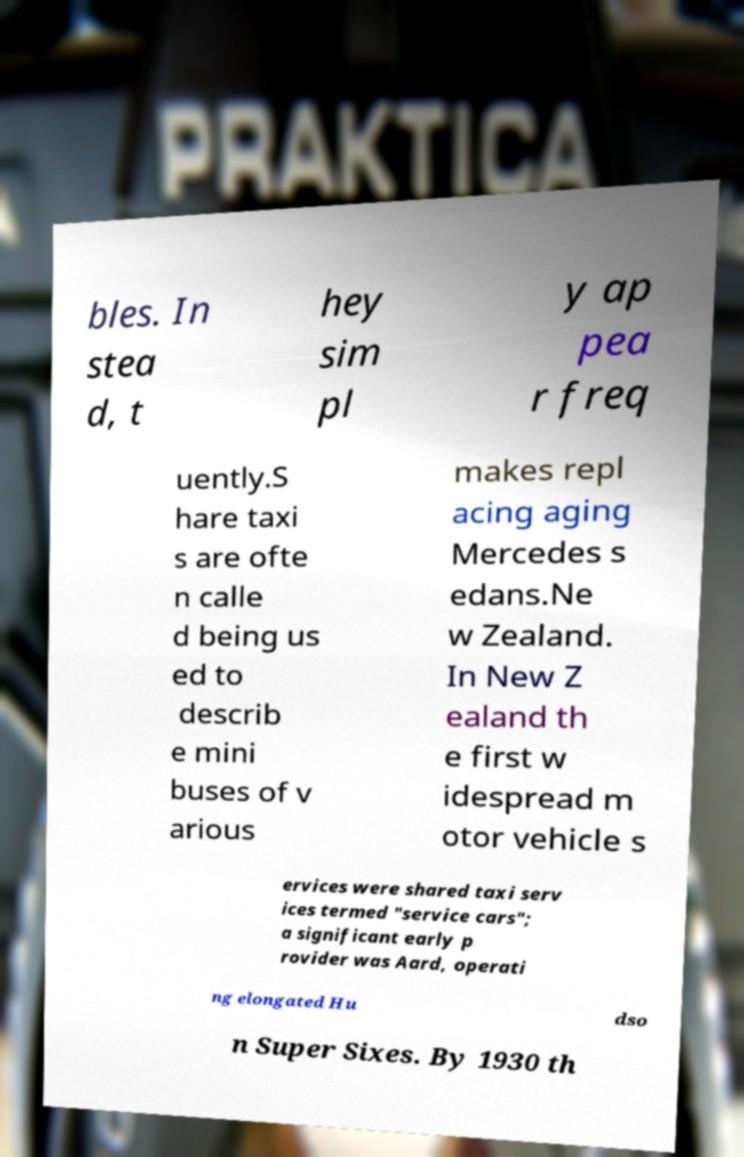For documentation purposes, I need the text within this image transcribed. Could you provide that? bles. In stea d, t hey sim pl y ap pea r freq uently.S hare taxi s are ofte n calle d being us ed to describ e mini buses of v arious makes repl acing aging Mercedes s edans.Ne w Zealand. In New Z ealand th e first w idespread m otor vehicle s ervices were shared taxi serv ices termed "service cars"; a significant early p rovider was Aard, operati ng elongated Hu dso n Super Sixes. By 1930 th 